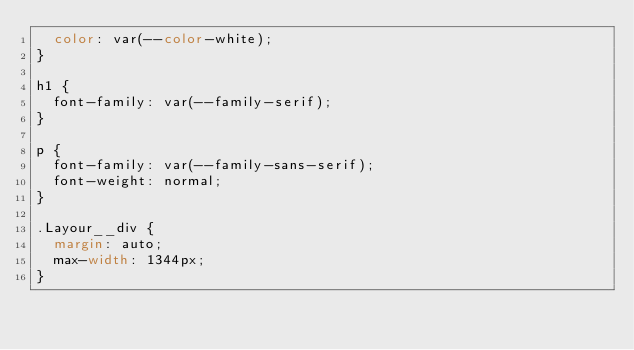Convert code to text. <code><loc_0><loc_0><loc_500><loc_500><_CSS_>  color: var(--color-white);
}

h1 {
  font-family: var(--family-serif);
}

p {
  font-family: var(--family-sans-serif);
  font-weight: normal;
}

.Layour__div {
  margin: auto;
  max-width: 1344px;
}
</code> 